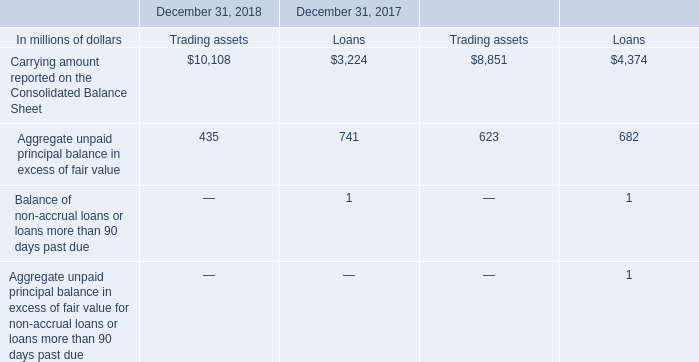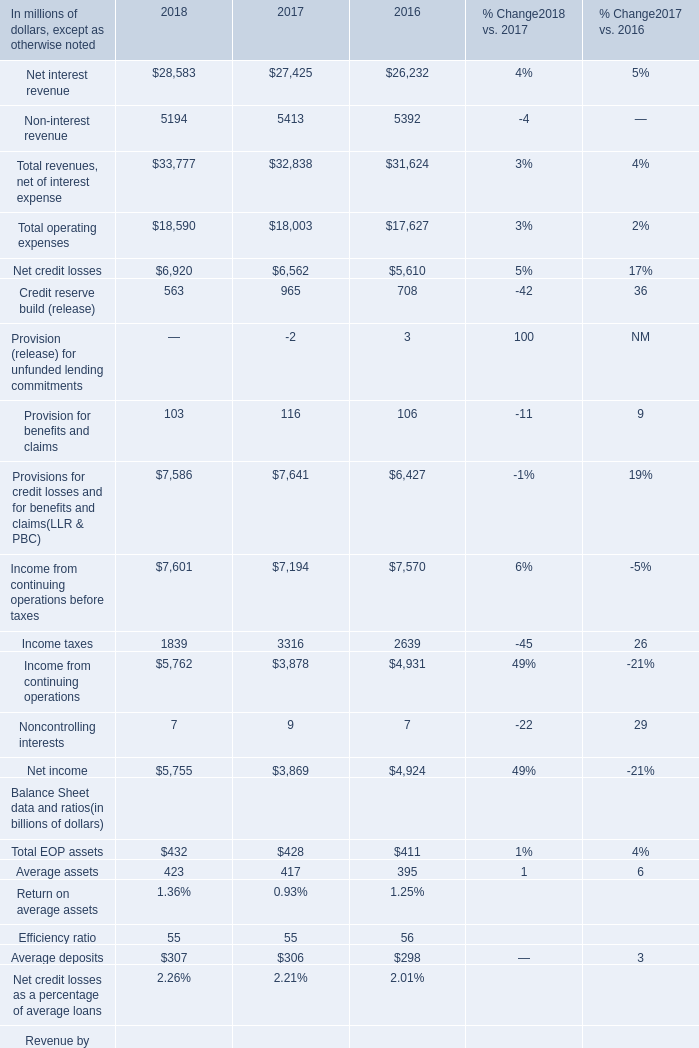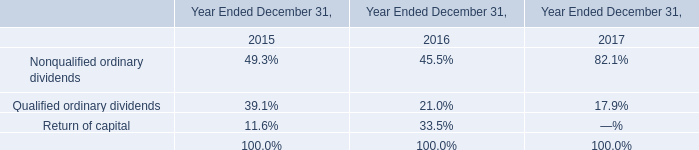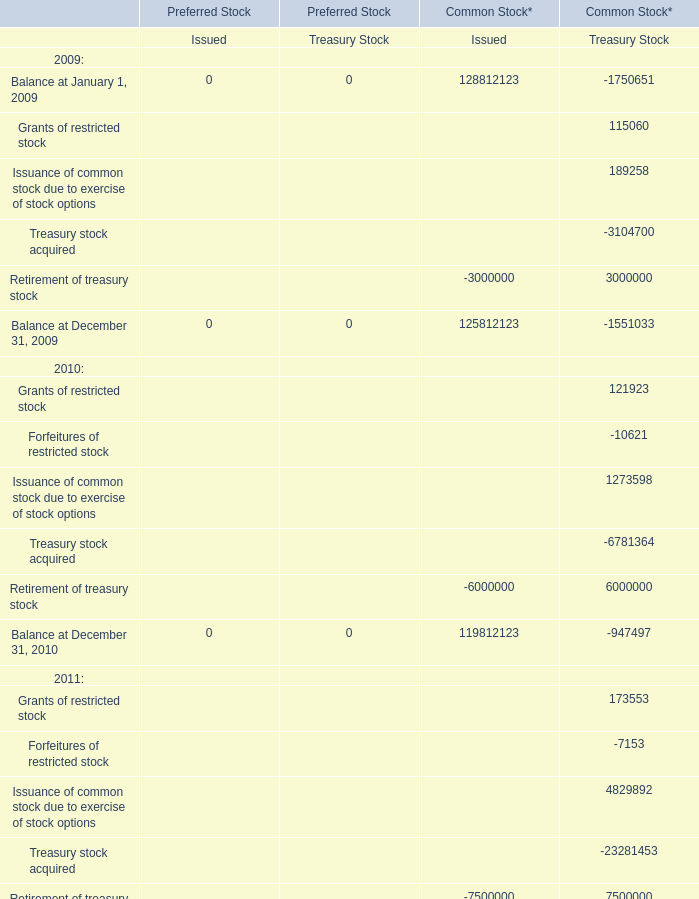If net income develops with the same growth rate in 2018, what will it reach in 2019? (in million) 
Computations: ((((5755 - 3869) / 3869) + 1) * 5755)
Answer: 8560.35797. 